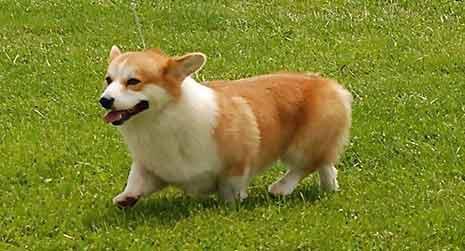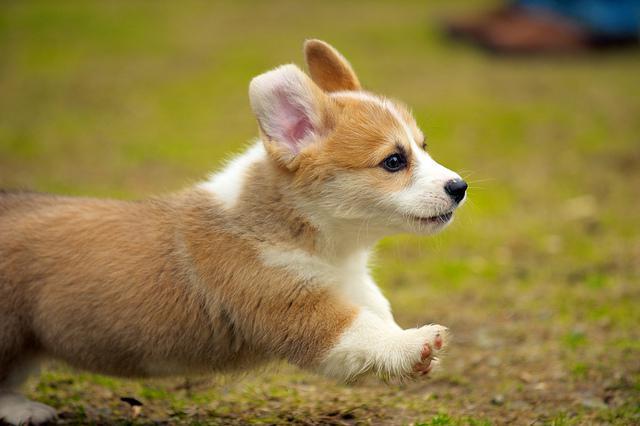The first image is the image on the left, the second image is the image on the right. Assess this claim about the two images: "The dogs in the images are in profile, with one body turned to the right and the other to the left.". Correct or not? Answer yes or no. Yes. 